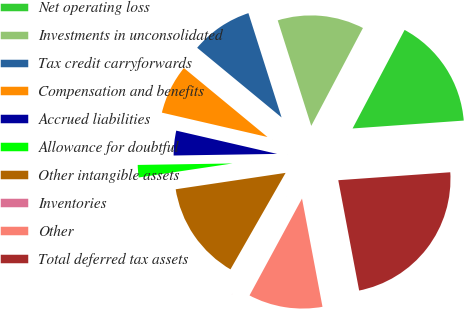<chart> <loc_0><loc_0><loc_500><loc_500><pie_chart><fcel>Net operating loss<fcel>Investments in unconsolidated<fcel>Tax credit carryforwards<fcel>Compensation and benefits<fcel>Accrued liabilities<fcel>Allowance for doubtful<fcel>Other intangible assets<fcel>Inventories<fcel>Other<fcel>Total deferred tax assets<nl><fcel>16.14%<fcel>12.63%<fcel>9.12%<fcel>7.37%<fcel>3.86%<fcel>2.11%<fcel>14.38%<fcel>0.36%<fcel>10.88%<fcel>23.15%<nl></chart> 